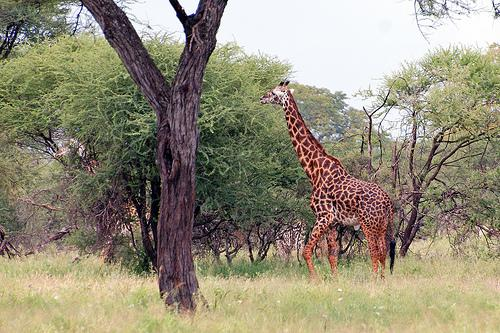Question: what season was this photo taken?
Choices:
A. Fall.
B. Summer.
C. Winter.
D. Spring.
Answer with the letter. Answer: D Question: when was this scene taken?
Choices:
A. Yesterday.
B. Today.
C. Last week.
D. Last month.
Answer with the letter. Answer: A Question: how many giraffes are there?
Choices:
A. Two.
B. One.
C. Three.
D. Four.
Answer with the letter. Answer: B 